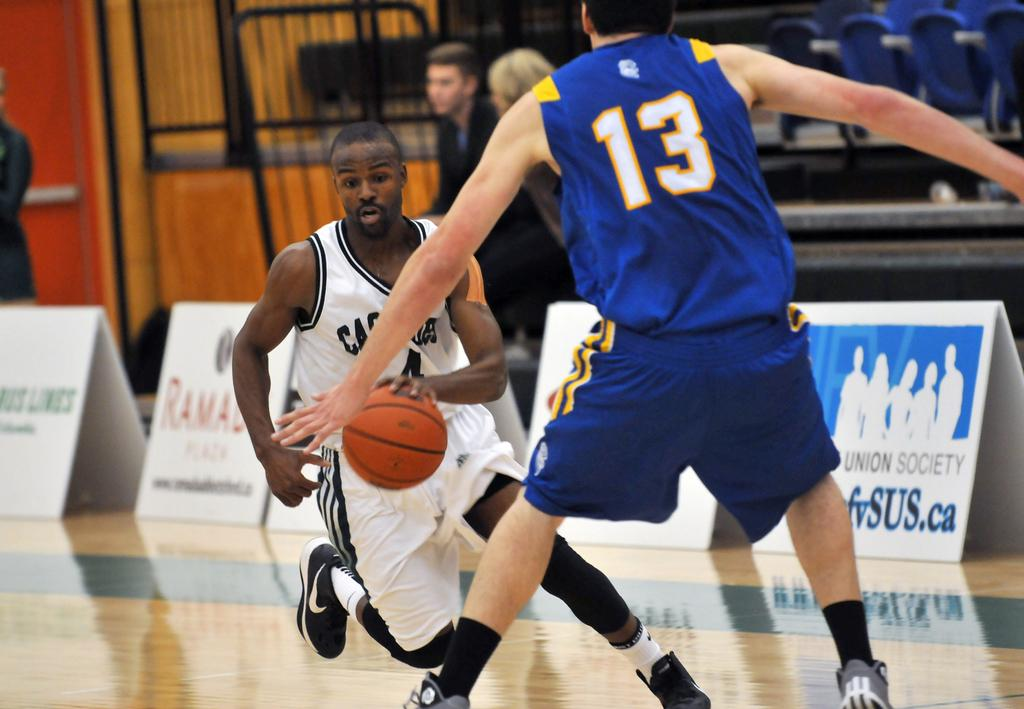<image>
Render a clear and concise summary of the photo. The basketball player in the number 13 jersey is blocking the other player in the white jersey. 